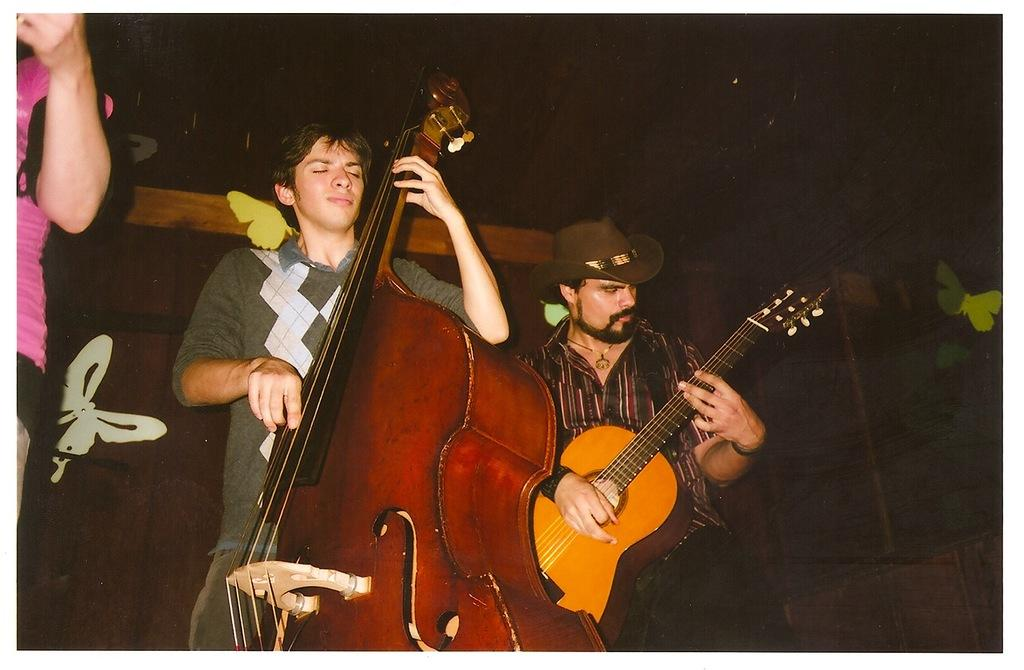How many people are in the image? There are two persons in the image. What are the persons doing in the image? Both persons are playing a guitar. Can you describe any accessories worn by one of the persons? One person is wearing a hat. What type of tin can be seen in the image? There is no tin present in the image. Can you describe the cat in the image? There is no cat present in the image. 